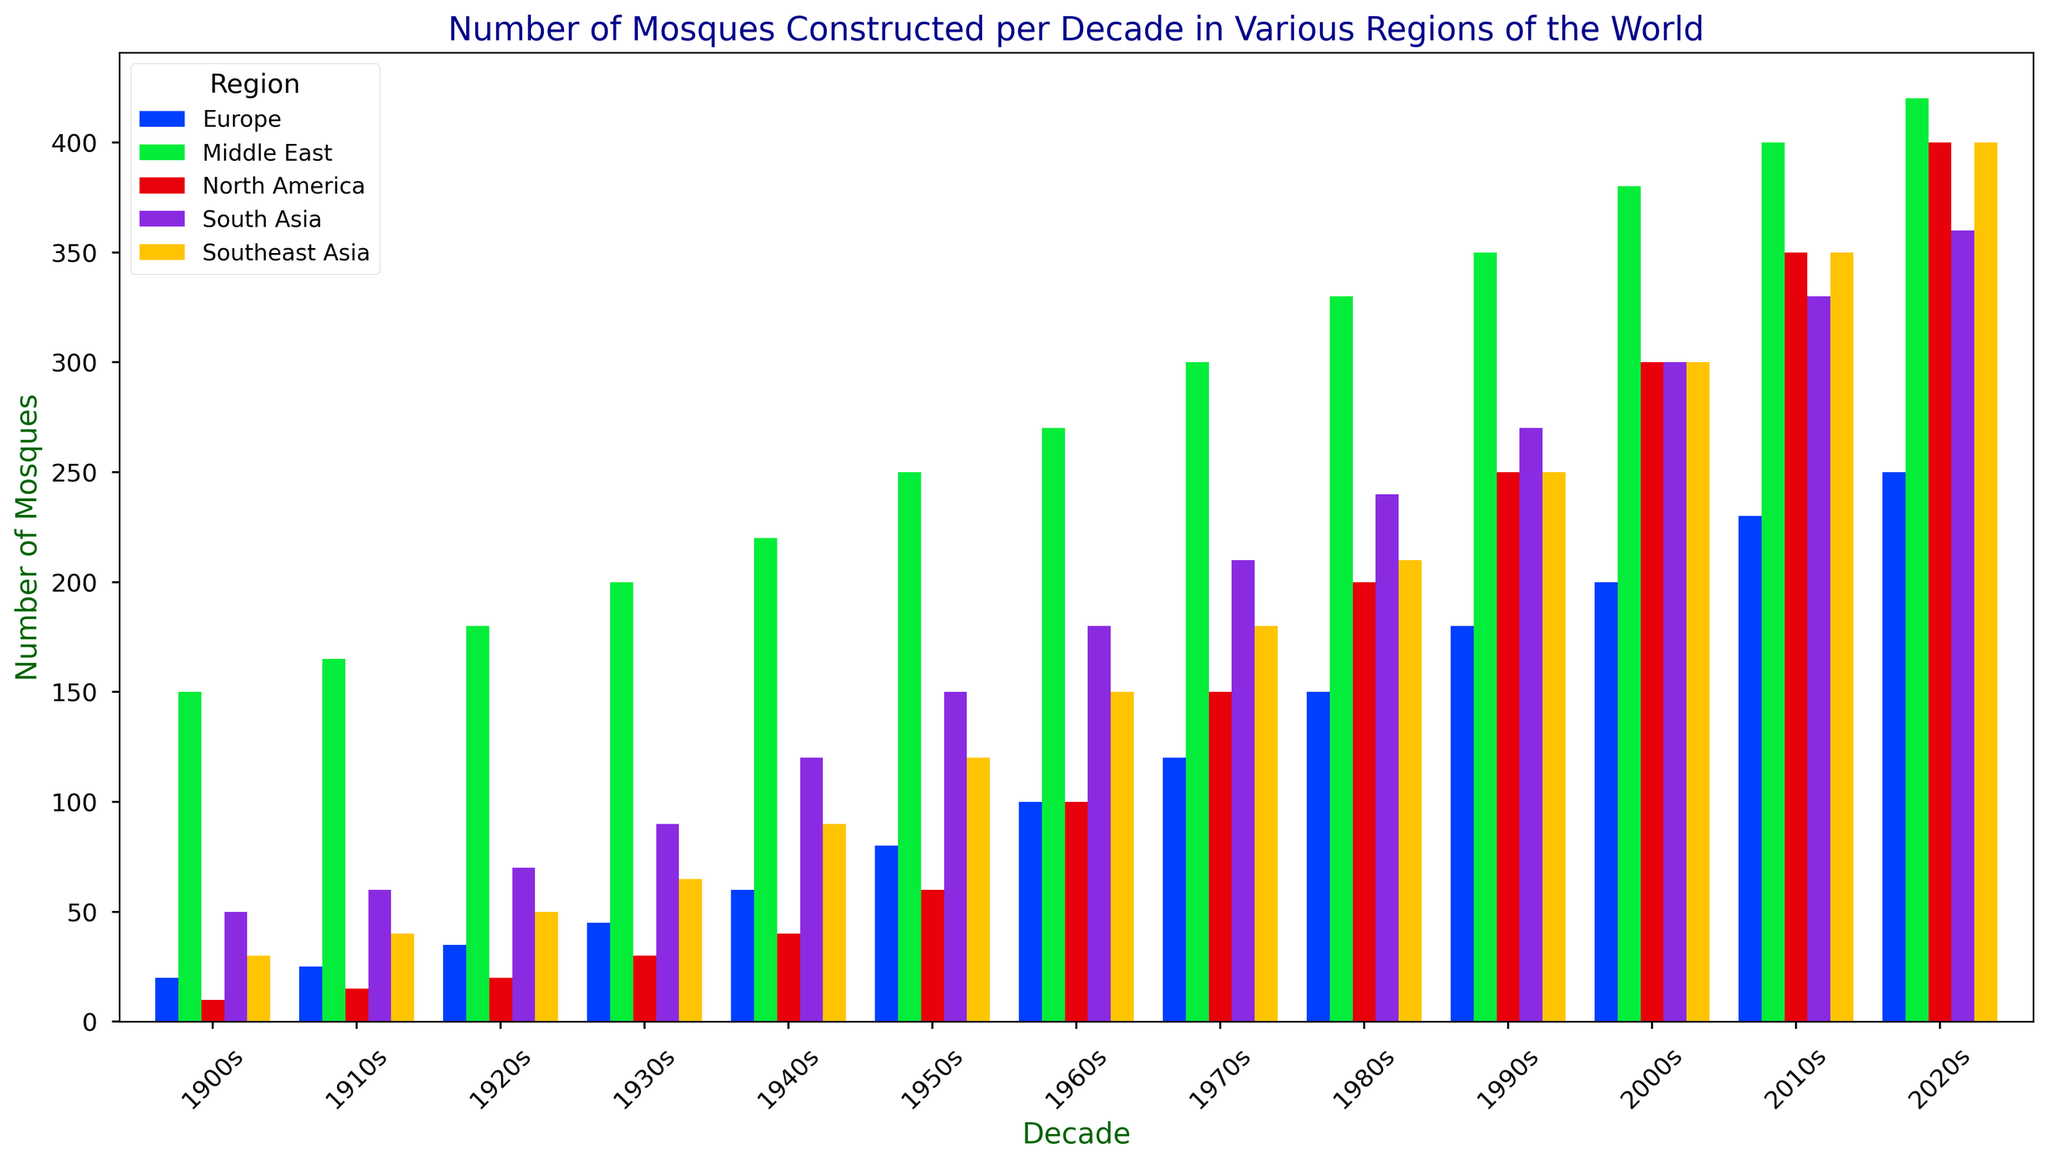What region experienced the highest number of mosques built in the 2020s? Look at the 2020s column and observe the height of the bars for each region. The tallest bar indicates the highest number of mosques built.
Answer: Middle East How does the number of mosques built in North America in the 1910s compare to the 2010s? Compare the heights of the bars for North America in the 1910s and the 2010s. The bar for the 2010s is significantly taller.
Answer: The number increased Which decade saw the greatest increase in the number of mosques for South Asia? Calculate the difference in the number of mosques between consecutive decades for South Asia and find the maximum difference.
Answer: 1930s How many mosques were built in Europe during the 1950s, 1960s, and 1970s combined? Sum the number of mosques in Europe during the 1950s, 1960s, and 1970s. 80 + 100 + 120 = 300
Answer: 300 In which region did the number of mosques exhibit the most steady increase per decade throughout the entire time period? Observe the general trend of the bars over time for each region. Identify the region without erratic changes and with a steady increase.
Answer: Middle East How does the number of mosques built in Southeast Asia in the 1940s compare to that in the 1980s? Compare the heights of the bars for Southeast Asia in the 1940s and the 1980s. The bar for the 1980s is taller.
Answer: The number increased Which region had the lowest initial number of mosques in the 1900s, and how does it compare to that region's count in the 2020s? Identify the region with the shortest bar in the 1900s and compare it to the same region's bar in the 2020s. North America had 10 mosques in the 1900s and 400 in the 2020s.
Answer: North America, 400 What is the average number of mosques built across all decades in the Middle East? Sum the number of mosques for all decades in the Middle East and divide by the number of decades (13). Total = 3685, Average = 3685 / 13 ≈ 283.46
Answer: Approximately 283 Compare the total number of mosques built in the 2000s across all regions. Which region had the highest contribution? Sum the number of mosques for each region in the 2000s and compare. Middle East: 380, North America: 300, Europe: 200, South Asia: 300, Southeast Asia: 300. The Middle East has the highest contribution.
Answer: Middle East 